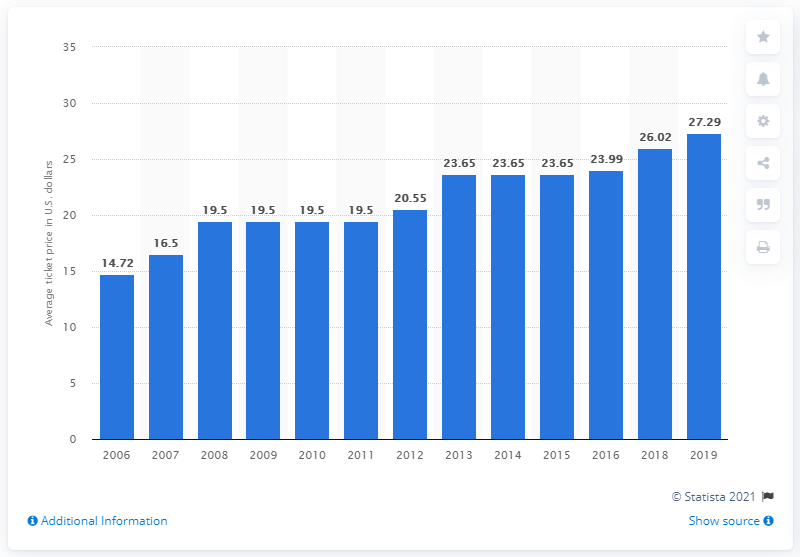Specify some key components in this picture. The average ticket price for Colorado Rockies games in 2019 was $27.29. 